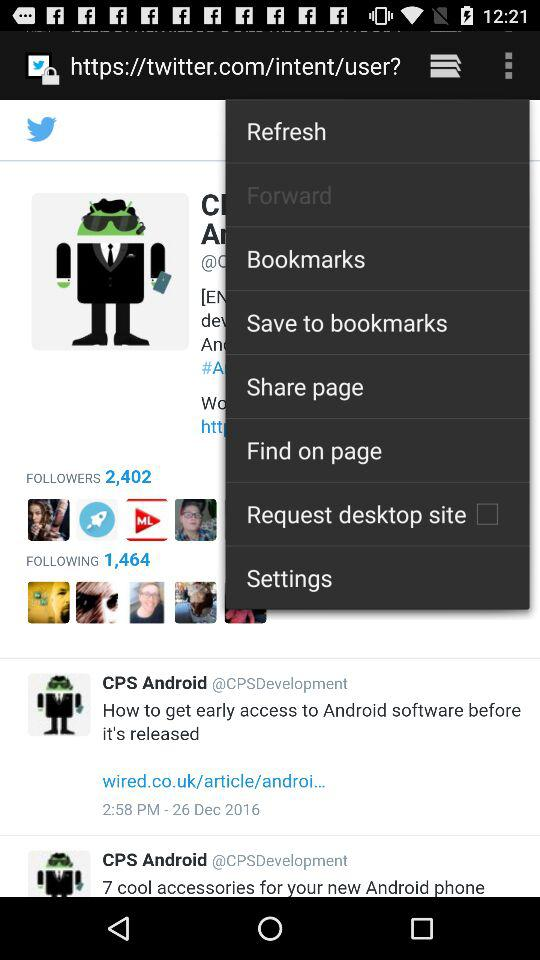What is the name of the application? The name of the application is Twitter. 